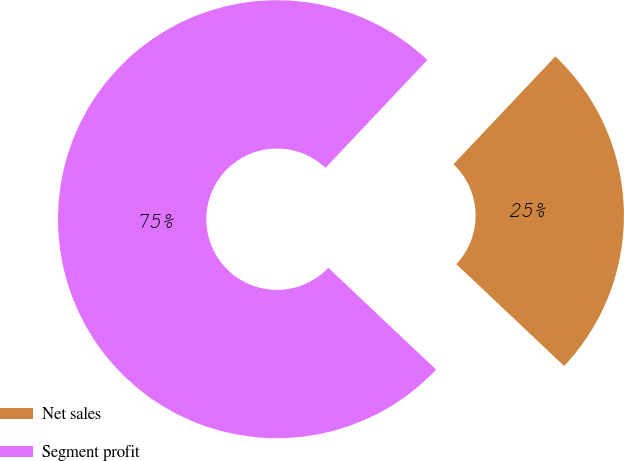Convert chart. <chart><loc_0><loc_0><loc_500><loc_500><pie_chart><fcel>Net sales<fcel>Segment profit<nl><fcel>25.0%<fcel>75.0%<nl></chart> 